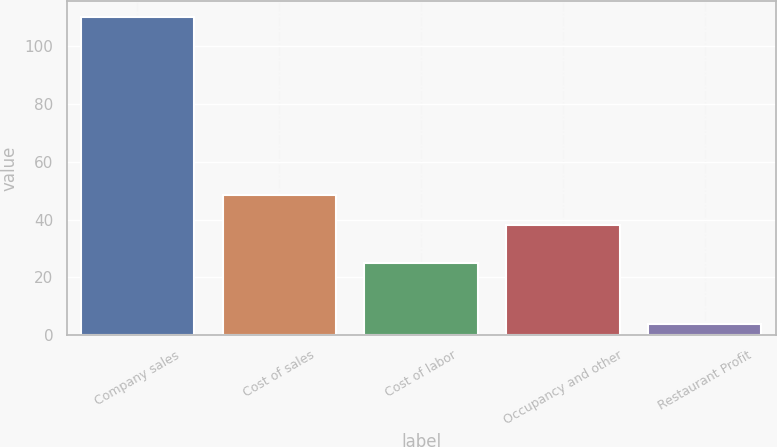Convert chart to OTSL. <chart><loc_0><loc_0><loc_500><loc_500><bar_chart><fcel>Company sales<fcel>Cost of sales<fcel>Cost of labor<fcel>Occupancy and other<fcel>Restaurant Profit<nl><fcel>110<fcel>48.6<fcel>25<fcel>38<fcel>4<nl></chart> 